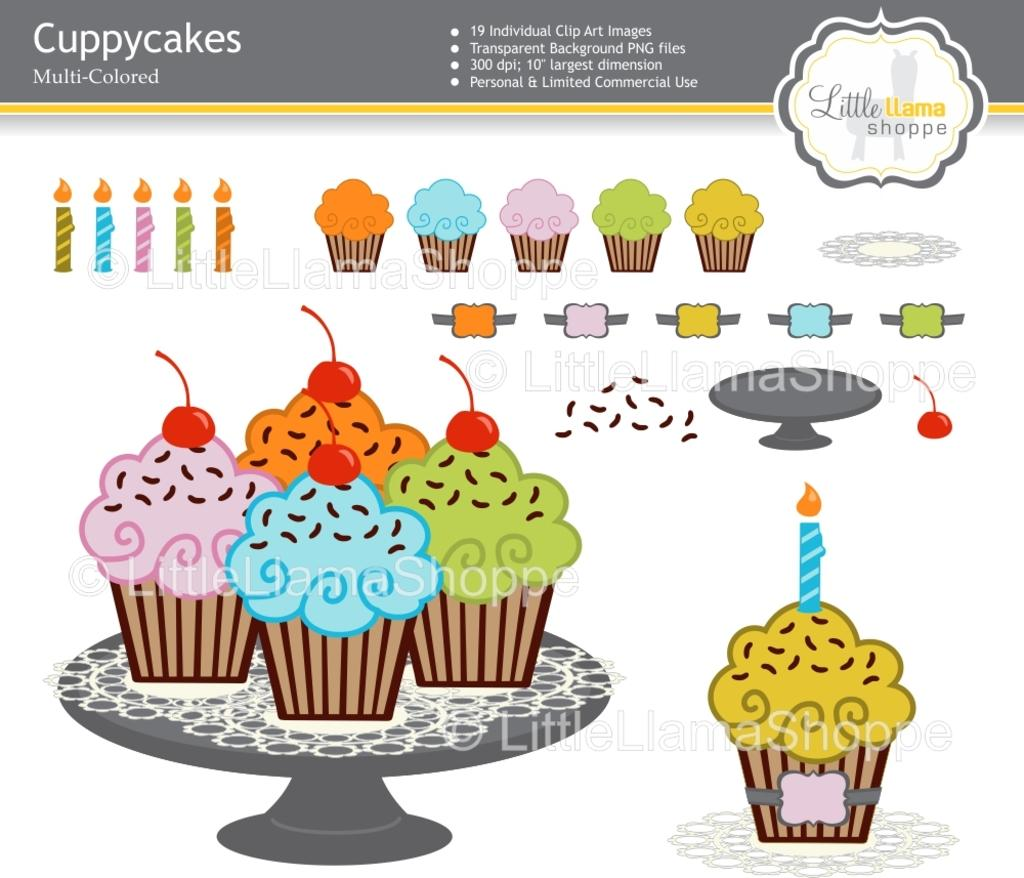What is the main subject of the poster in the image? The poster contains images of cupcakes and candles. Are there any other objects depicted on the poster? Yes, there are other objects depicted on the poster. What can be found on the poster besides images? There is text on the poster. What type of mint is used as bait for the ray in the image? There is no mint, bait, or ray present in the image; it only features a poster with images and text. 